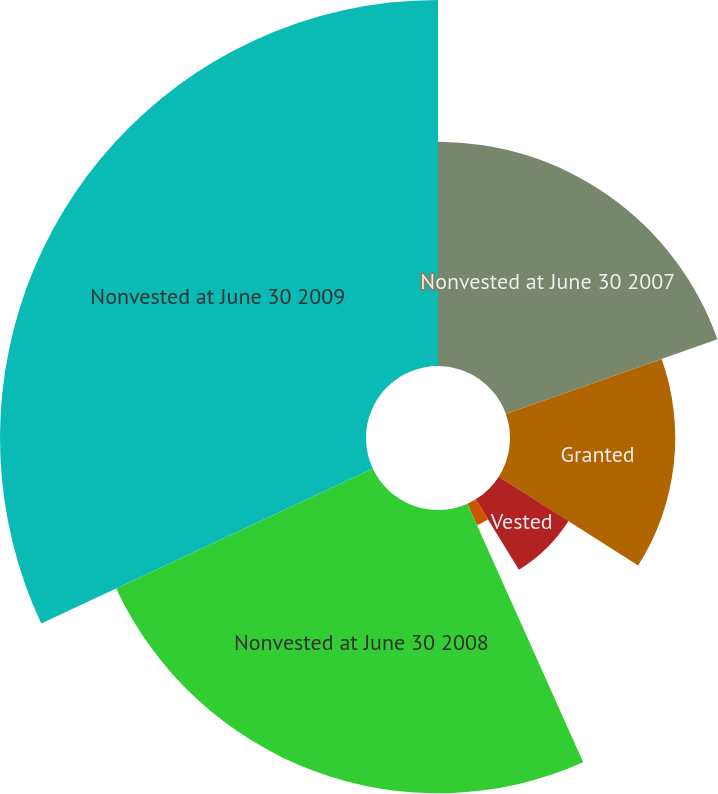Convert chart to OTSL. <chart><loc_0><loc_0><loc_500><loc_500><pie_chart><fcel>Nonvested at June 30 2007<fcel>Granted<fcel>Vested<fcel>Forfeited<fcel>Nonvested at June 30 2008<fcel>Nonvested at June 30 2009<nl><fcel>19.59%<fcel>14.43%<fcel>7.22%<fcel>2.06%<fcel>24.74%<fcel>31.96%<nl></chart> 